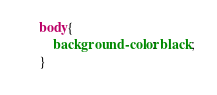<code> <loc_0><loc_0><loc_500><loc_500><_CSS_>body{
    background-color: black;
}</code> 